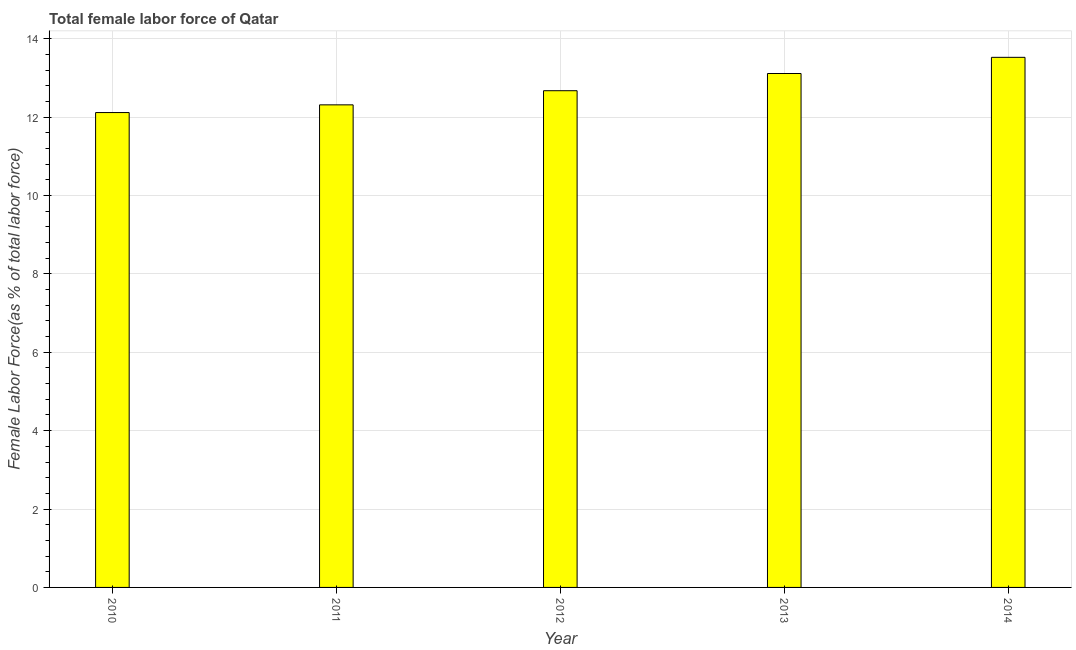Does the graph contain any zero values?
Provide a short and direct response. No. Does the graph contain grids?
Make the answer very short. Yes. What is the title of the graph?
Ensure brevity in your answer.  Total female labor force of Qatar. What is the label or title of the X-axis?
Keep it short and to the point. Year. What is the label or title of the Y-axis?
Keep it short and to the point. Female Labor Force(as % of total labor force). What is the total female labor force in 2011?
Your answer should be compact. 12.31. Across all years, what is the maximum total female labor force?
Offer a terse response. 13.53. Across all years, what is the minimum total female labor force?
Offer a very short reply. 12.12. In which year was the total female labor force maximum?
Give a very brief answer. 2014. In which year was the total female labor force minimum?
Provide a succinct answer. 2010. What is the sum of the total female labor force?
Your answer should be very brief. 63.74. What is the difference between the total female labor force in 2010 and 2013?
Provide a short and direct response. -1. What is the average total female labor force per year?
Offer a very short reply. 12.75. What is the median total female labor force?
Offer a very short reply. 12.67. What is the ratio of the total female labor force in 2010 to that in 2014?
Offer a terse response. 0.9. Is the total female labor force in 2011 less than that in 2014?
Your answer should be very brief. Yes. Is the difference between the total female labor force in 2012 and 2013 greater than the difference between any two years?
Your answer should be very brief. No. What is the difference between the highest and the second highest total female labor force?
Provide a short and direct response. 0.41. What is the difference between the highest and the lowest total female labor force?
Your answer should be very brief. 1.41. How many bars are there?
Provide a succinct answer. 5. Are all the bars in the graph horizontal?
Give a very brief answer. No. What is the difference between two consecutive major ticks on the Y-axis?
Your answer should be compact. 2. What is the Female Labor Force(as % of total labor force) of 2010?
Your response must be concise. 12.12. What is the Female Labor Force(as % of total labor force) in 2011?
Ensure brevity in your answer.  12.31. What is the Female Labor Force(as % of total labor force) of 2012?
Make the answer very short. 12.67. What is the Female Labor Force(as % of total labor force) in 2013?
Your response must be concise. 13.11. What is the Female Labor Force(as % of total labor force) in 2014?
Your answer should be compact. 13.53. What is the difference between the Female Labor Force(as % of total labor force) in 2010 and 2011?
Provide a succinct answer. -0.2. What is the difference between the Female Labor Force(as % of total labor force) in 2010 and 2012?
Offer a terse response. -0.56. What is the difference between the Female Labor Force(as % of total labor force) in 2010 and 2013?
Provide a short and direct response. -1. What is the difference between the Female Labor Force(as % of total labor force) in 2010 and 2014?
Keep it short and to the point. -1.41. What is the difference between the Female Labor Force(as % of total labor force) in 2011 and 2012?
Your response must be concise. -0.36. What is the difference between the Female Labor Force(as % of total labor force) in 2011 and 2013?
Offer a very short reply. -0.8. What is the difference between the Female Labor Force(as % of total labor force) in 2011 and 2014?
Provide a succinct answer. -1.21. What is the difference between the Female Labor Force(as % of total labor force) in 2012 and 2013?
Make the answer very short. -0.44. What is the difference between the Female Labor Force(as % of total labor force) in 2012 and 2014?
Your answer should be compact. -0.85. What is the difference between the Female Labor Force(as % of total labor force) in 2013 and 2014?
Provide a short and direct response. -0.41. What is the ratio of the Female Labor Force(as % of total labor force) in 2010 to that in 2011?
Ensure brevity in your answer.  0.98. What is the ratio of the Female Labor Force(as % of total labor force) in 2010 to that in 2012?
Ensure brevity in your answer.  0.96. What is the ratio of the Female Labor Force(as % of total labor force) in 2010 to that in 2013?
Your response must be concise. 0.92. What is the ratio of the Female Labor Force(as % of total labor force) in 2010 to that in 2014?
Provide a short and direct response. 0.9. What is the ratio of the Female Labor Force(as % of total labor force) in 2011 to that in 2013?
Your answer should be very brief. 0.94. What is the ratio of the Female Labor Force(as % of total labor force) in 2011 to that in 2014?
Your answer should be compact. 0.91. What is the ratio of the Female Labor Force(as % of total labor force) in 2012 to that in 2014?
Provide a succinct answer. 0.94. 